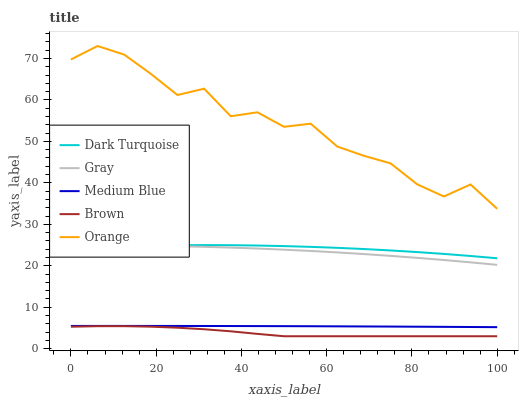Does Brown have the minimum area under the curve?
Answer yes or no. Yes. Does Orange have the maximum area under the curve?
Answer yes or no. Yes. Does Dark Turquoise have the minimum area under the curve?
Answer yes or no. No. Does Dark Turquoise have the maximum area under the curve?
Answer yes or no. No. Is Medium Blue the smoothest?
Answer yes or no. Yes. Is Orange the roughest?
Answer yes or no. Yes. Is Dark Turquoise the smoothest?
Answer yes or no. No. Is Dark Turquoise the roughest?
Answer yes or no. No. Does Dark Turquoise have the lowest value?
Answer yes or no. No. Does Orange have the highest value?
Answer yes or no. Yes. Does Dark Turquoise have the highest value?
Answer yes or no. No. Is Brown less than Medium Blue?
Answer yes or no. Yes. Is Orange greater than Gray?
Answer yes or no. Yes. Does Gray intersect Dark Turquoise?
Answer yes or no. Yes. Is Gray less than Dark Turquoise?
Answer yes or no. No. Is Gray greater than Dark Turquoise?
Answer yes or no. No. Does Brown intersect Medium Blue?
Answer yes or no. No. 